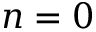<formula> <loc_0><loc_0><loc_500><loc_500>n = 0</formula> 